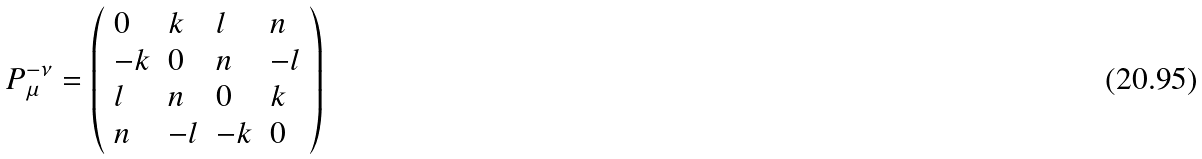<formula> <loc_0><loc_0><loc_500><loc_500>P _ { \mu } ^ { - \nu } = \left ( \begin{array} { l l l l } 0 & k & l & n \\ - k & 0 & n & - l \\ l & n & 0 & k \\ n & - l & - k & 0 \end{array} \right )</formula> 